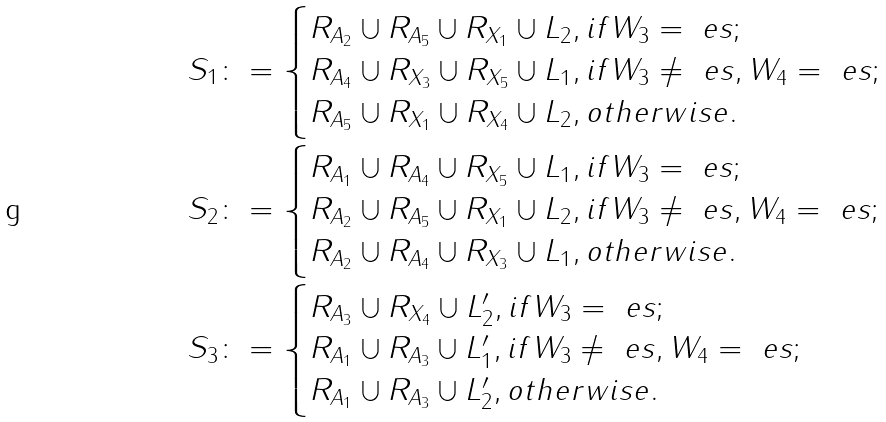<formula> <loc_0><loc_0><loc_500><loc_500>& S _ { 1 } \colon = \begin{cases} R _ { A _ { 2 } } \cup R _ { A _ { 5 } } \cup R _ { X _ { 1 } } \cup L _ { 2 } , i f W _ { 3 } = \ e s ; \\ R _ { A _ { 4 } } \cup R _ { X _ { 3 } } \cup R _ { X _ { 5 } } \cup L _ { 1 } , i f W _ { 3 } \neq \ e s , W _ { 4 } = \ e s ; \\ R _ { A _ { 5 } } \cup R _ { X _ { 1 } } \cup R _ { X _ { 4 } } \cup L _ { 2 } , o t h e r w i s e . \\ \end{cases} \\ & S _ { 2 } \colon = \begin{cases} R _ { A _ { 1 } } \cup R _ { A _ { 4 } } \cup R _ { X _ { 5 } } \cup L _ { 1 } , i f W _ { 3 } = \ e s ; \\ R _ { A _ { 2 } } \cup R _ { A _ { 5 } } \cup R _ { X _ { 1 } } \cup L _ { 2 } , i f W _ { 3 } \neq \ e s , W _ { 4 } = \ e s ; \\ R _ { A _ { 2 } } \cup R _ { A _ { 4 } } \cup R _ { X _ { 3 } } \cup L _ { 1 } , o t h e r w i s e . \\ \end{cases} \\ & S _ { 3 } \colon = \begin{cases} R _ { A _ { 3 } } \cup R _ { X _ { 4 } } \cup L _ { 2 } ^ { \prime } , i f W _ { 3 } = \ e s ; \\ R _ { A _ { 1 } } \cup R _ { A _ { 3 } } \cup L _ { 1 } ^ { \prime } , i f W _ { 3 } \neq \ e s , W _ { 4 } = \ e s ; \\ R _ { A _ { 1 } } \cup R _ { A _ { 3 } } \cup L _ { 2 } ^ { \prime } , o t h e r w i s e . \\ \end{cases}</formula> 